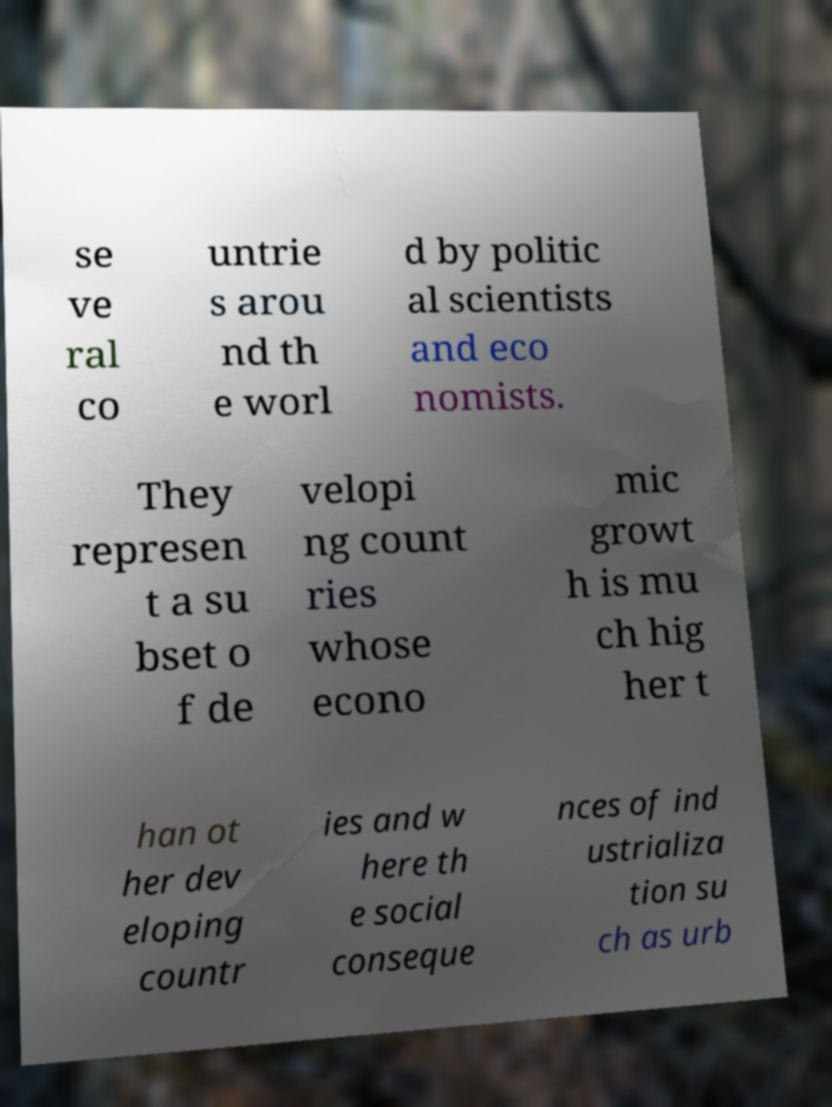Please read and relay the text visible in this image. What does it say? se ve ral co untrie s arou nd th e worl d by politic al scientists and eco nomists. They represen t a su bset o f de velopi ng count ries whose econo mic growt h is mu ch hig her t han ot her dev eloping countr ies and w here th e social conseque nces of ind ustrializa tion su ch as urb 